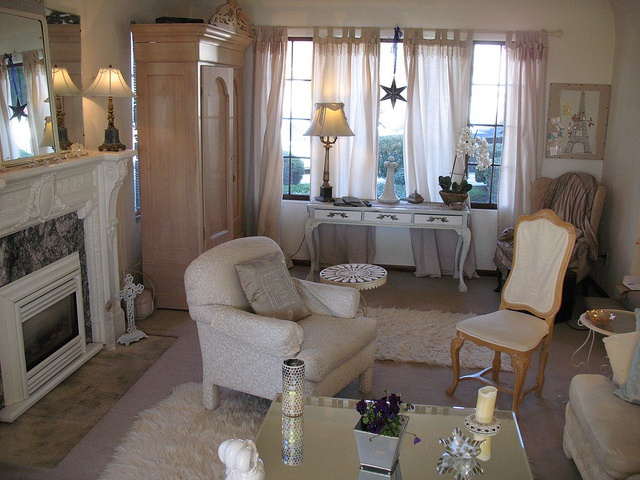Describe the objects in this image and their specific colors. I can see chair in black, darkgray, and gray tones, chair in black, darkgray, gray, and maroon tones, chair in black, gray, and maroon tones, potted plant in black and gray tones, and potted plant in black and gray tones in this image. 